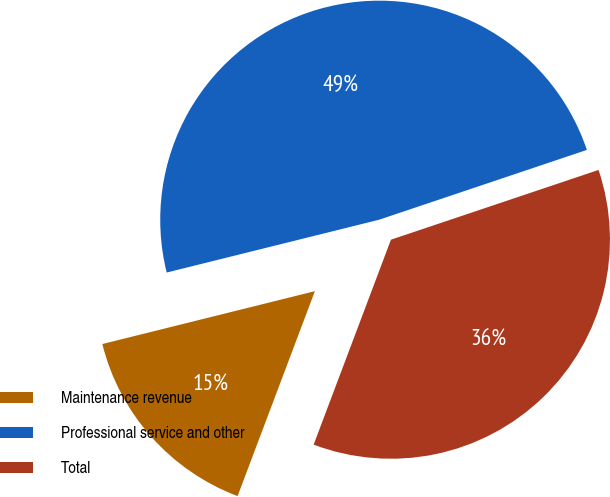Convert chart. <chart><loc_0><loc_0><loc_500><loc_500><pie_chart><fcel>Maintenance revenue<fcel>Professional service and other<fcel>Total<nl><fcel>15.38%<fcel>48.72%<fcel>35.9%<nl></chart> 